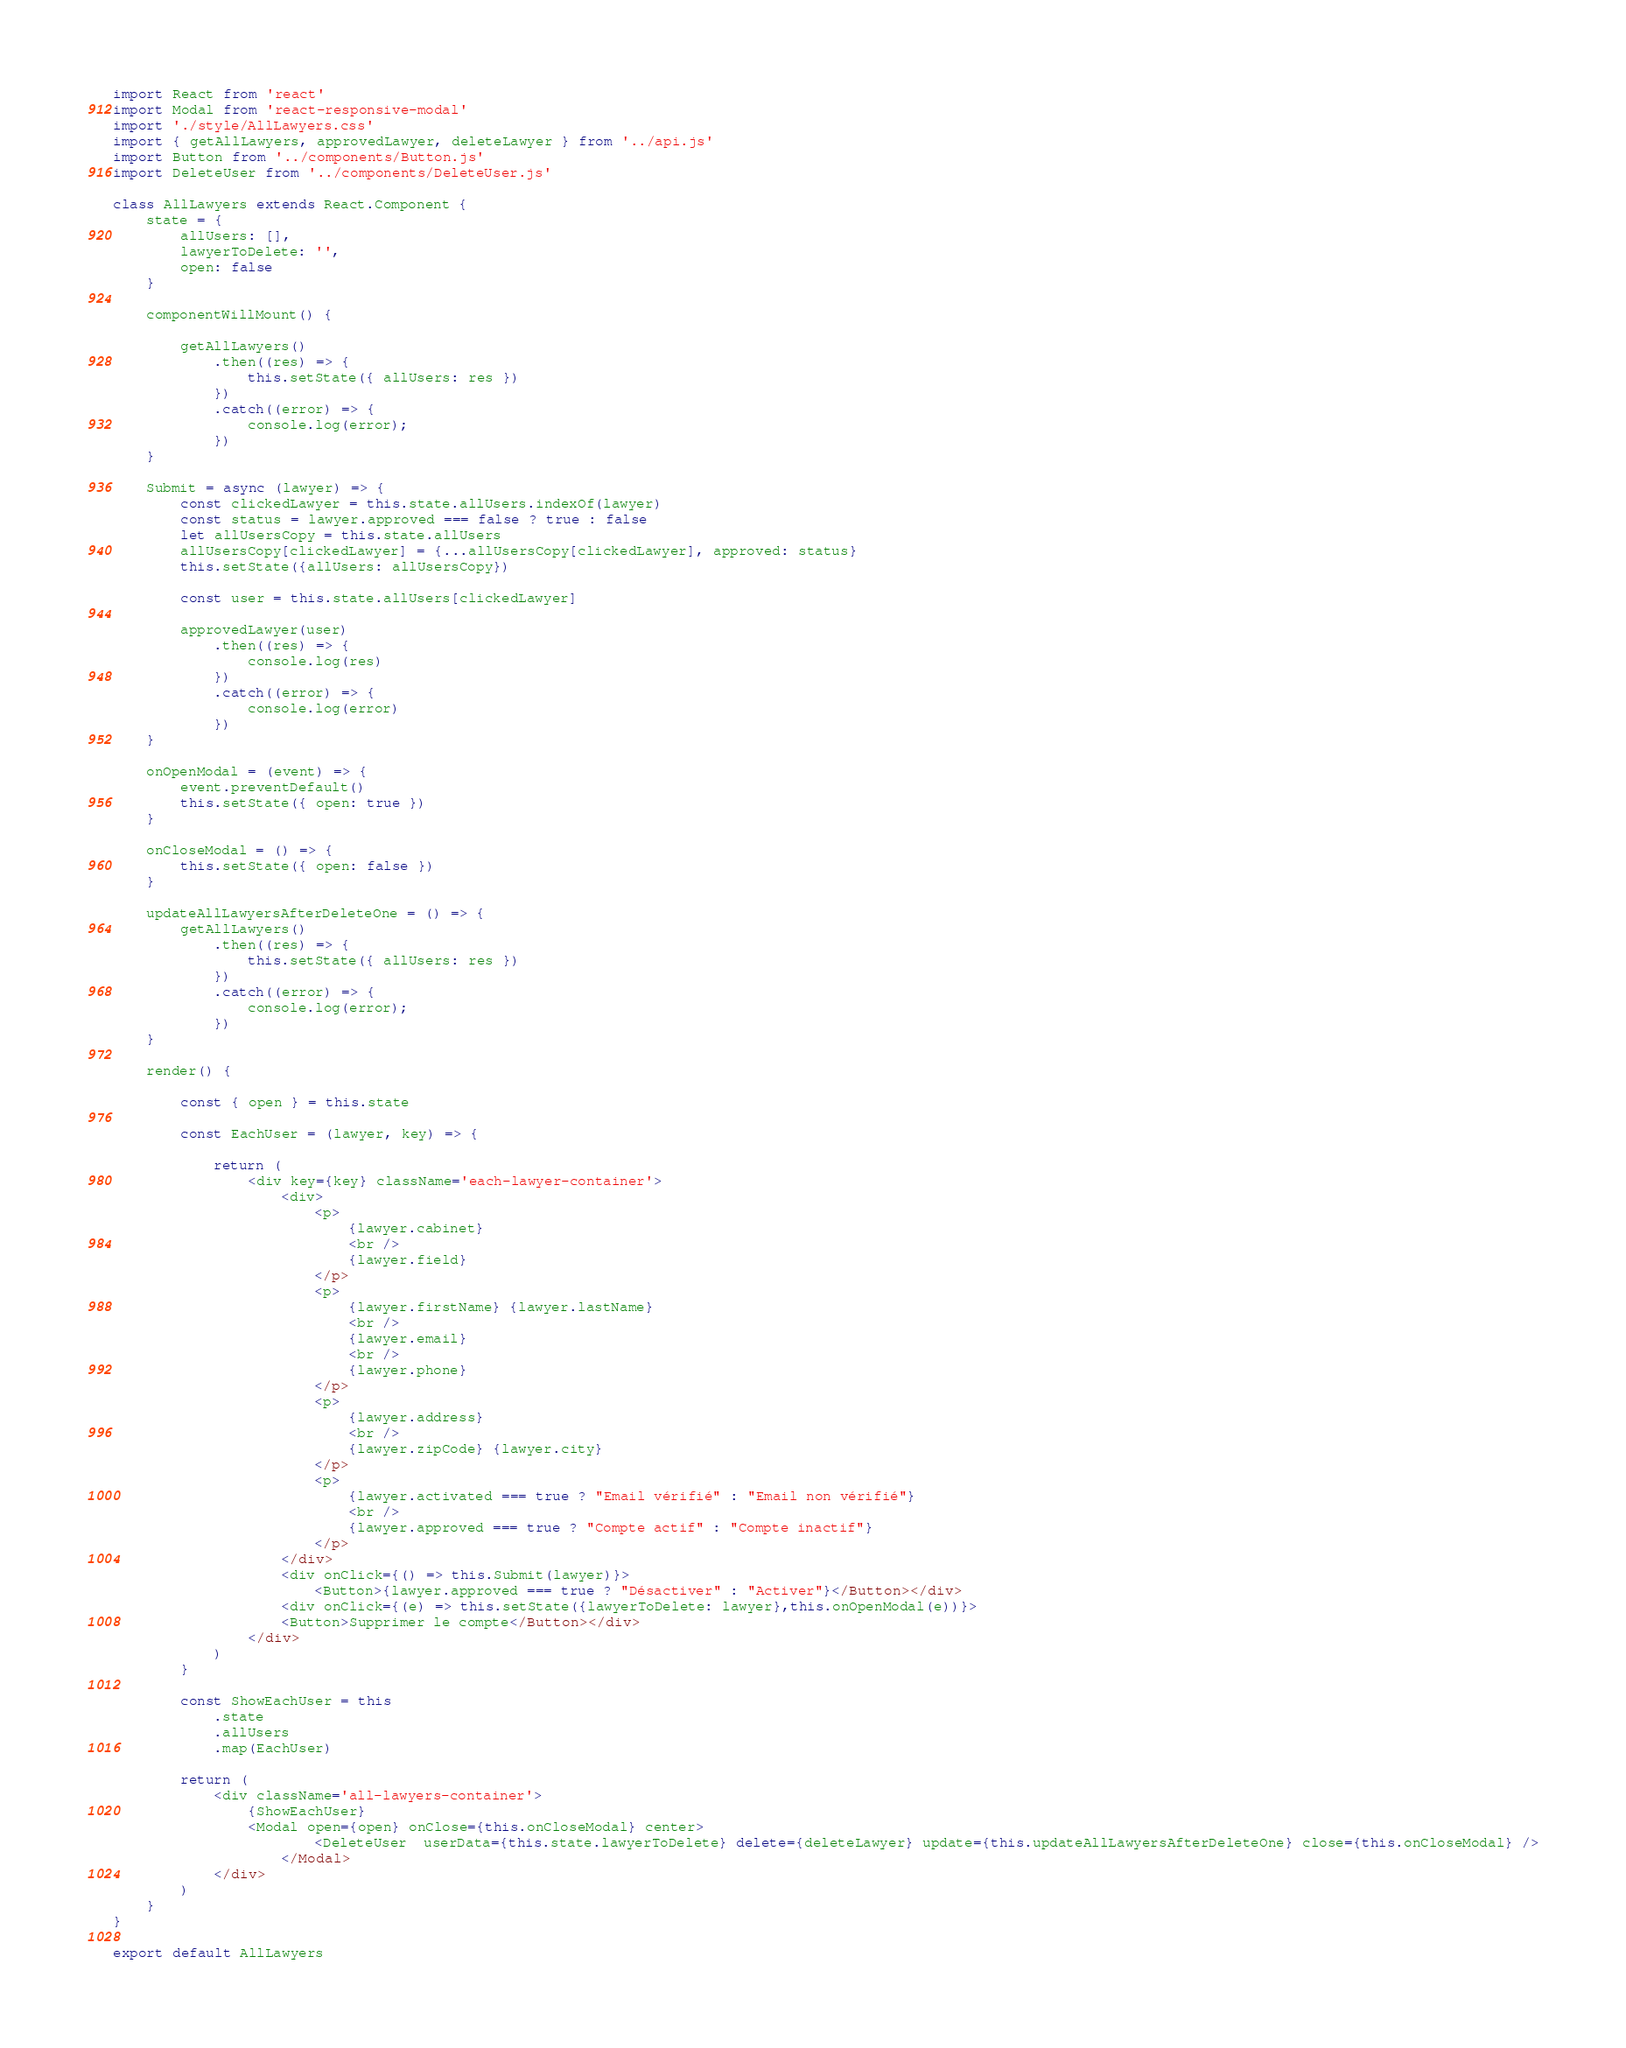Convert code to text. <code><loc_0><loc_0><loc_500><loc_500><_JavaScript_>import React from 'react'
import Modal from 'react-responsive-modal'
import './style/AllLawyers.css'
import { getAllLawyers, approvedLawyer, deleteLawyer } from '../api.js'
import Button from '../components/Button.js'
import DeleteUser from '../components/DeleteUser.js'

class AllLawyers extends React.Component {
	state = {
		allUsers: [],
		lawyerToDelete: '',
		open: false
	}

	componentWillMount() {

		getAllLawyers()
			.then((res) => {
				this.setState({ allUsers: res })
			})
			.catch((error) => {
				console.log(error);
			})
	}

	Submit = async (lawyer) => {
		const clickedLawyer = this.state.allUsers.indexOf(lawyer)
		const status = lawyer.approved === false ? true : false
		let allUsersCopy = this.state.allUsers
		allUsersCopy[clickedLawyer] = {...allUsersCopy[clickedLawyer], approved: status}
		this.setState({allUsers: allUsersCopy})

		const user = this.state.allUsers[clickedLawyer]

		approvedLawyer(user)
			.then((res) => {
				console.log(res)
			})
			.catch((error) => {
				console.log(error)
			})
	}

	onOpenModal = (event) => {
		event.preventDefault()
		this.setState({ open: true })
	}

	onCloseModal = () => {
		this.setState({ open: false })
	}

	updateAllLawyersAfterDeleteOne = () => {
		getAllLawyers()
			.then((res) => {
				this.setState({ allUsers: res })
			})
			.catch((error) => {
				console.log(error);
			})
	}

	render() {

		const { open } = this.state

		const EachUser = (lawyer, key) => {

			return (
				<div key={key} className='each-lawyer-container'>
					<div>
						<p>
							{lawyer.cabinet}
							<br />
							{lawyer.field}
						</p>
						<p>
							{lawyer.firstName} {lawyer.lastName}
							<br />
							{lawyer.email}
							<br />
							{lawyer.phone}
						</p>
						<p>
							{lawyer.address}
							<br />
							{lawyer.zipCode} {lawyer.city}
						</p>
						<p>
							{lawyer.activated === true ? "Email vérifié" : "Email non vérifié"}
							<br />
							{lawyer.approved === true ? "Compte actif" : "Compte inactif"}
						</p>
					</div>
					<div onClick={() => this.Submit(lawyer)}>
						<Button>{lawyer.approved === true ? "Désactiver" : "Activer"}</Button></div>
					<div onClick={(e) => this.setState({lawyerToDelete: lawyer},this.onOpenModal(e))}>
					<Button>Supprimer le compte</Button></div>
				</div>
			)
		}

		const ShowEachUser = this
			.state
			.allUsers
			.map(EachUser)

		return (
			<div className='all-lawyers-container'>
				{ShowEachUser}
				<Modal open={open} onClose={this.onCloseModal} center>
						<DeleteUser  userData={this.state.lawyerToDelete} delete={deleteLawyer} update={this.updateAllLawyersAfterDeleteOne} close={this.onCloseModal} />
					</Modal>
			</div>
		)
	}
}

export default AllLawyers
</code> 